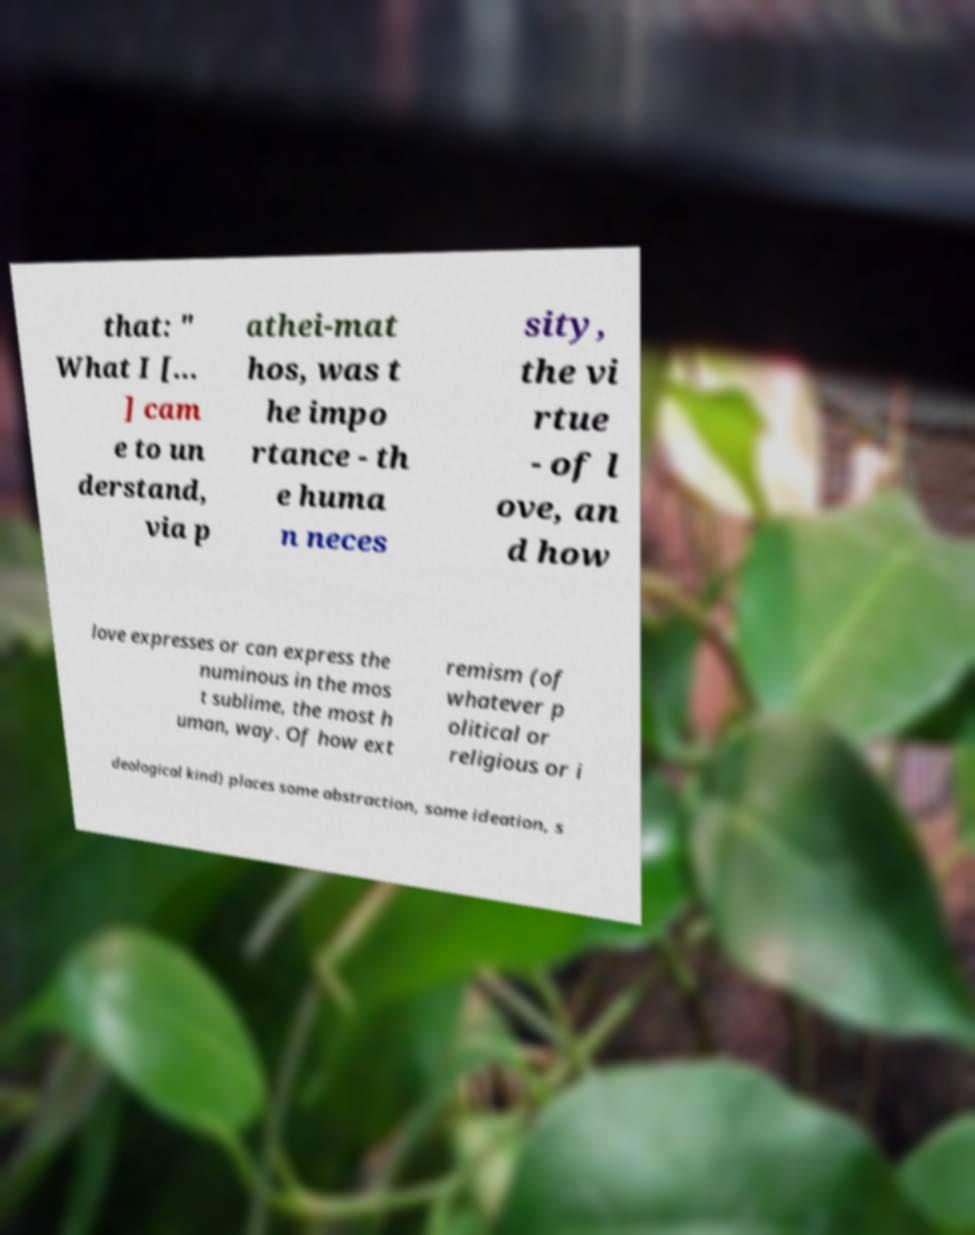Could you assist in decoding the text presented in this image and type it out clearly? that: " What I [... ] cam e to un derstand, via p athei-mat hos, was t he impo rtance - th e huma n neces sity, the vi rtue - of l ove, an d how love expresses or can express the numinous in the mos t sublime, the most h uman, way. Of how ext remism (of whatever p olitical or religious or i deological kind) places some abstraction, some ideation, s 